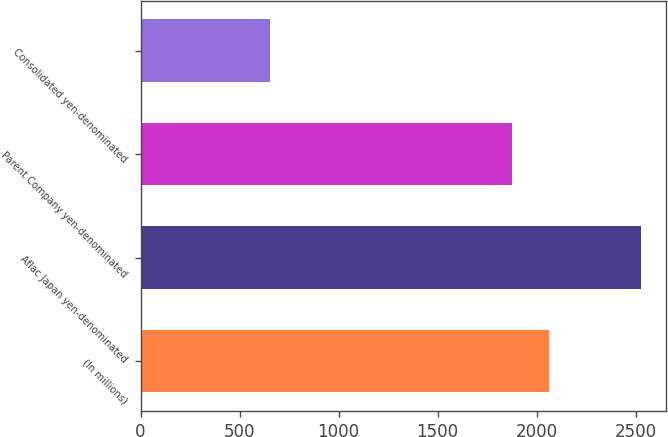<chart> <loc_0><loc_0><loc_500><loc_500><bar_chart><fcel>(In millions)<fcel>Aflac Japan yen-denominated<fcel>Parent Company yen-denominated<fcel>Consolidated yen-denominated<nl><fcel>2063.6<fcel>2528<fcel>1876<fcel>652<nl></chart> 